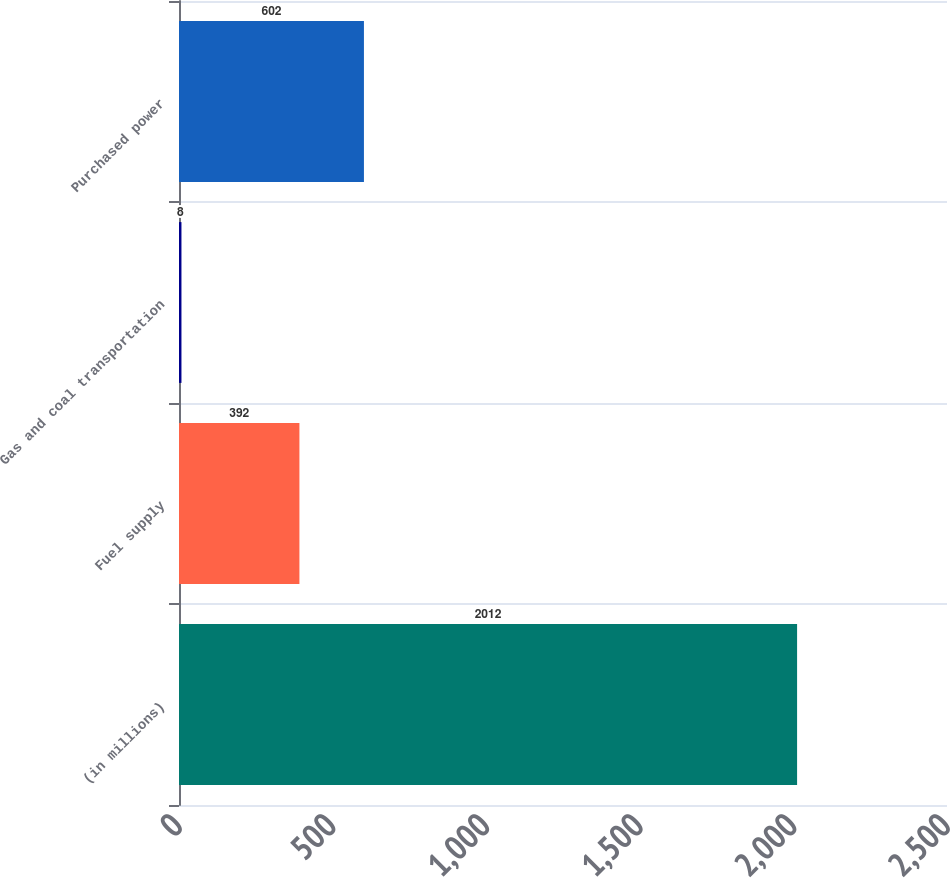Convert chart. <chart><loc_0><loc_0><loc_500><loc_500><bar_chart><fcel>(in millions)<fcel>Fuel supply<fcel>Gas and coal transportation<fcel>Purchased power<nl><fcel>2012<fcel>392<fcel>8<fcel>602<nl></chart> 